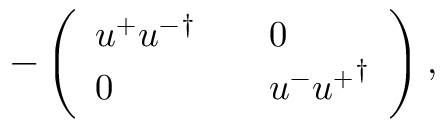<formula> <loc_0><loc_0><loc_500><loc_500>- \left ( \begin{array} { l l l } { { u ^ { + } { u ^ { - } } ^ { \dagger } } } & { 0 } \\ { 0 } & { { u ^ { - } { u ^ { + } } ^ { \dagger } } } \end{array} \right ) ,</formula> 